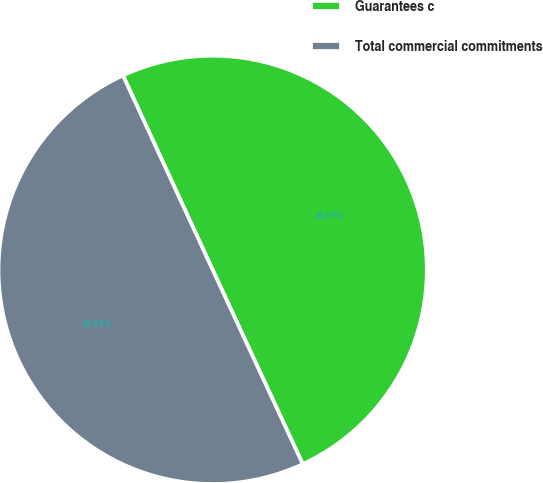Convert chart to OTSL. <chart><loc_0><loc_0><loc_500><loc_500><pie_chart><fcel>Guarantees c<fcel>Total commercial commitments<nl><fcel>49.97%<fcel>50.03%<nl></chart> 